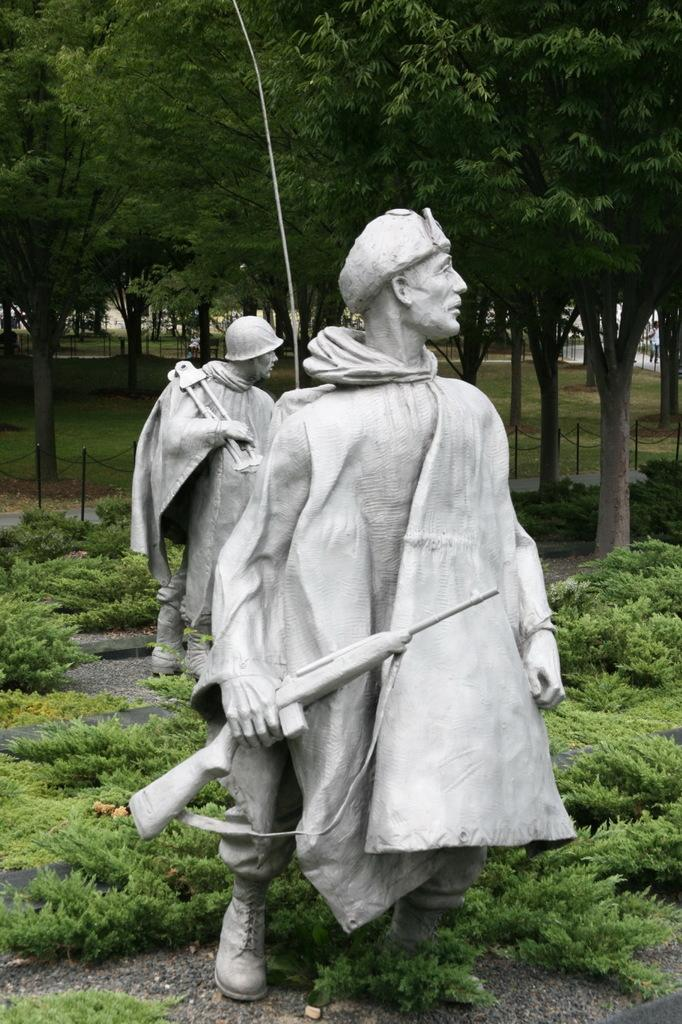What can be seen in the foreground of the image? There are statues in the foreground of the image. What is surrounding the statues? There are plants around the statues. What can be seen in the background of the image? There are trees in the background of the image. What type of square is the grandmother holding in the image? There is no grandmother or square present in the image. 